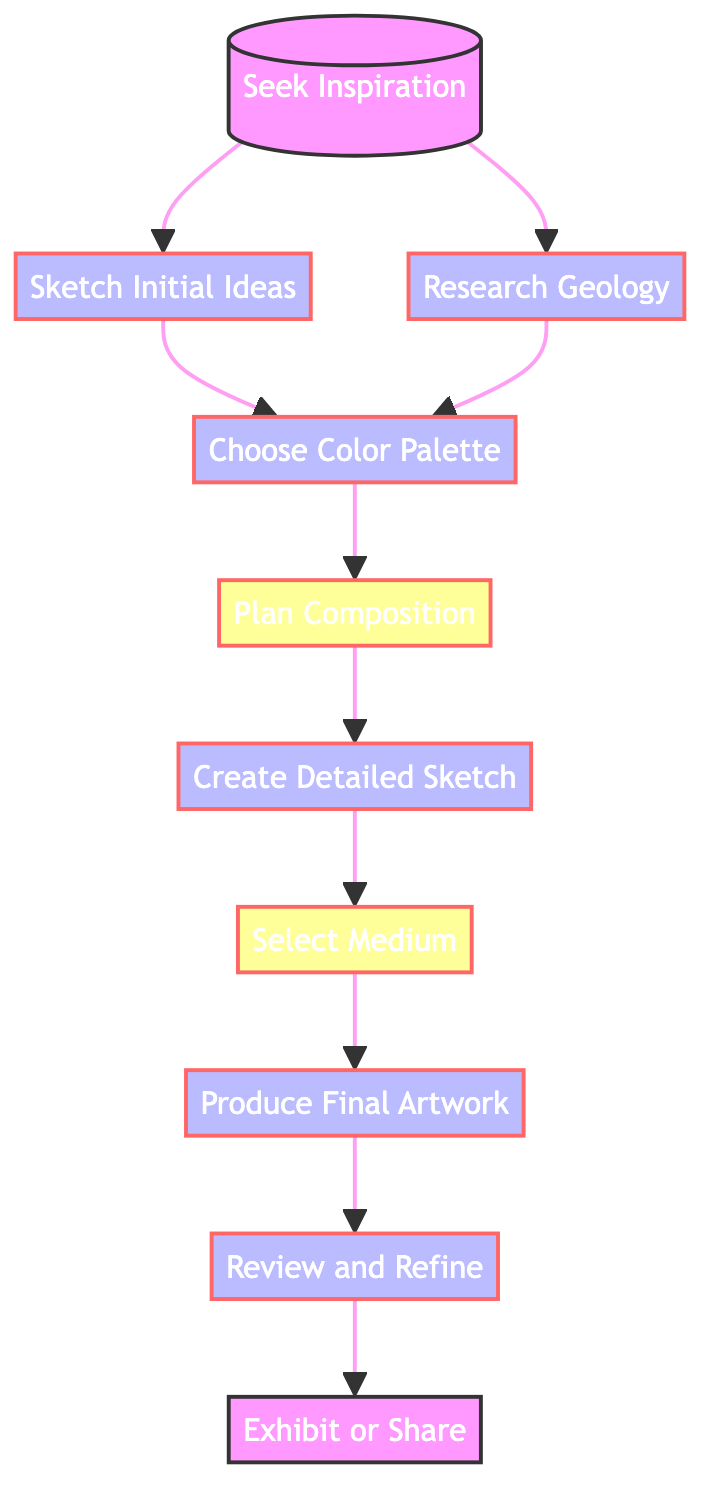What is the first step in the creative workflow? The first step in the workflow is "Seek Inspiration." This is indicated as the starting point of the flow chart, leading to other processes.
Answer: Seek Inspiration How many total nodes are in the diagram? By counting the distinct processes and decisions listed in the flow chart, we find there are ten nodes in total.
Answer: 10 What is the relationship between "Sketch Initial Ideas" and "Choose Color Palette"? "Sketch Initial Ideas" leads to "Choose Color Palette," indicating that sketching initial ideas is a prerequisite for selecting the colors.
Answer: Sequential Which step comes after creating a detailed sketch? After "Create Detailed Sketch," the next step is "Select Medium," as shown by the forward link in the flow chart.
Answer: Select Medium What are the last two steps in the workflow? The last two steps in the workflow, following the process, are "Review and Refine" and "Exhibit or Share." These are the final actions that wrap up the creative process.
Answer: Review and Refine, Exhibit or Share What is the last decision node in the workflow? The last decision node in the workflow is "Select Medium," which occurs before producing the final artwork. It indicates a choice that influences the final product.
Answer: Select Medium Which step is preceded by both "Sketch Initial Ideas" and "Research Geology"? The step "Choose Color Palette" is preceded by both "Sketch Initial Ideas" and "Research Geology," suggesting that both initial sketches and geological knowledge inform the color selection.
Answer: Choose Color Palette How many processes are there in total? By counting the nodes that are categorized as processes, there are eight processes in the workflow diagram.
Answer: 8 What is the purpose of the "Review and Refine" step? The purpose of the "Review and Refine" step is to evaluate the artwork and make adjustments, which is clearly stated in its description as the penultimate action.
Answer: Evaluate and adjust artwork 